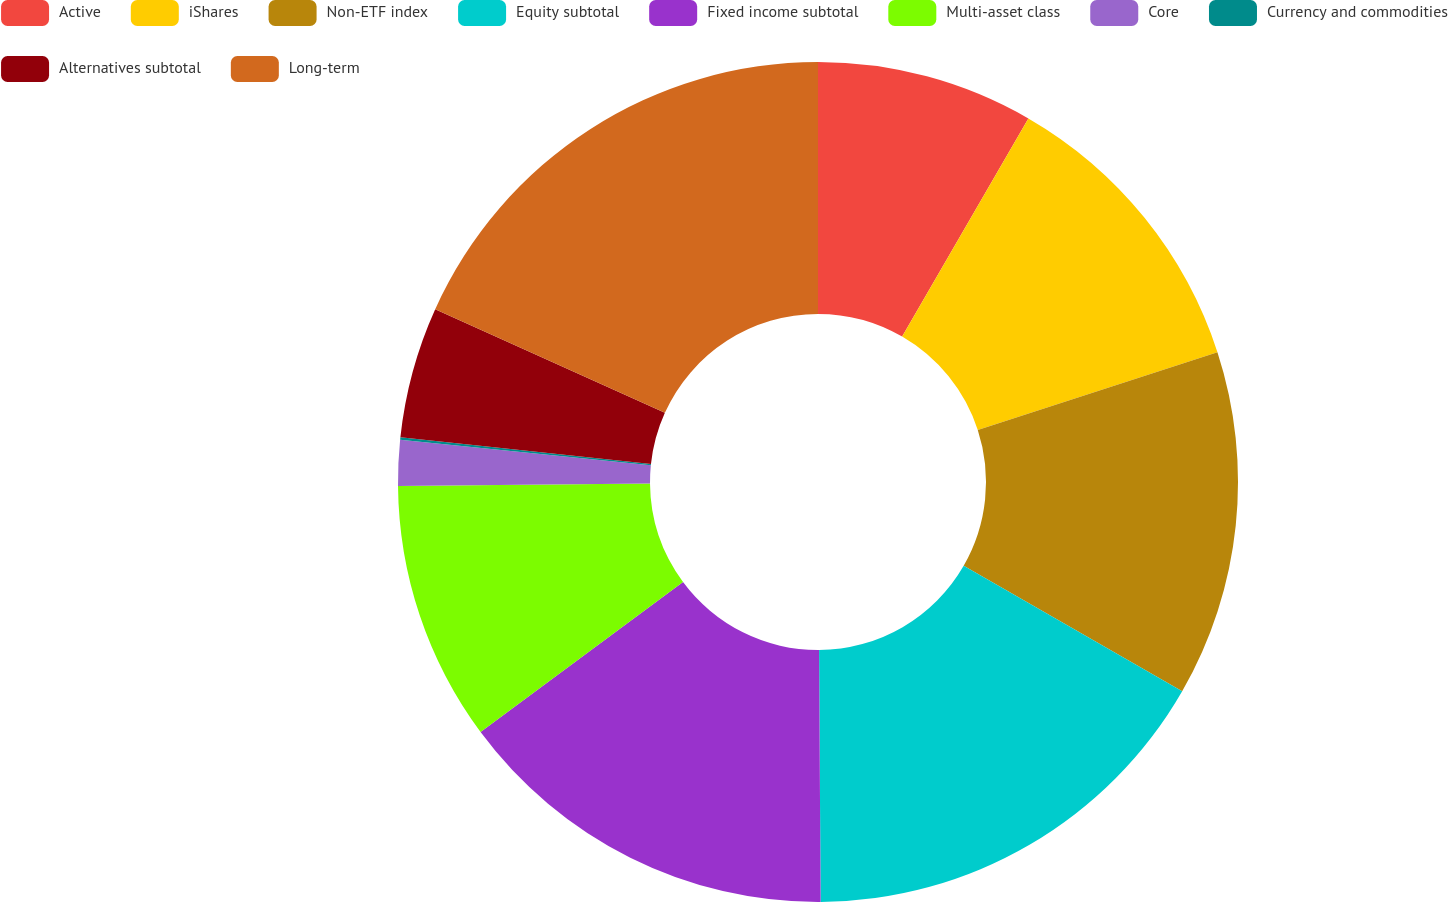<chart> <loc_0><loc_0><loc_500><loc_500><pie_chart><fcel>Active<fcel>iShares<fcel>Non-ETF index<fcel>Equity subtotal<fcel>Fixed income subtotal<fcel>Multi-asset class<fcel>Core<fcel>Currency and commodities<fcel>Alternatives subtotal<fcel>Long-term<nl><fcel>8.35%<fcel>11.65%<fcel>13.3%<fcel>16.6%<fcel>14.95%<fcel>10.0%<fcel>1.75%<fcel>0.1%<fcel>5.05%<fcel>18.25%<nl></chart> 